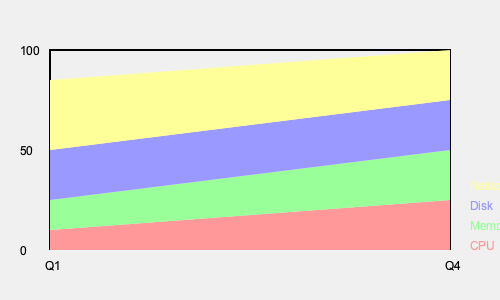Based on the stacked area chart showing system resource utilization over four quarters, which resource consistently shows the highest utilization throughout the year, and what trend does it exhibit? To answer this question, we need to analyze the stacked area chart systematically:

1. Identify the resources: The chart shows four system resources - CPU (red), Memory (green), Disk (blue), and Network (yellow).

2. Understand the chart structure: The x-axis represents time (Q1 to Q4), and the y-axis represents utilization percentage (0 to 100).

3. Analyze each resource's area:
   - CPU (red): Occupies the bottom area, showing relatively stable utilization.
   - Memory (green): Shows a slight decrease in utilization over time.
   - Disk (blue): Exhibits a moderate increase in utilization from Q1 to Q4.
   - Network (yellow): Occupies the top area, indicating the highest utilization.

4. Compare resource utilization:
   - Network consistently has the largest area across all quarters.
   - Other resources show varying trends but always remain below Network utilization.

5. Observe the trend for Network utilization:
   - The Network area slightly increases from Q1 to Q4, indicating a gradual upward trend.

Therefore, the Network resource consistently shows the highest utilization throughout the year, exhibiting a slight upward trend from Q1 to Q4.
Answer: Network; slight upward trend 